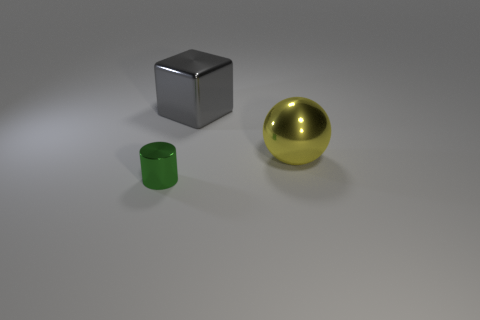Can you describe the lighting in the scene? The lighting in the scene appears to be diffused, with a soft shadow cast beneath each object, indicating an overhead light source that is not too harsh. There are no strong highlights, which suggests the lighting is even and possibly from a studio light setup or image rendering with a global illumination feature for realistic lighting. 